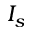Convert formula to latex. <formula><loc_0><loc_0><loc_500><loc_500>I _ { s }</formula> 